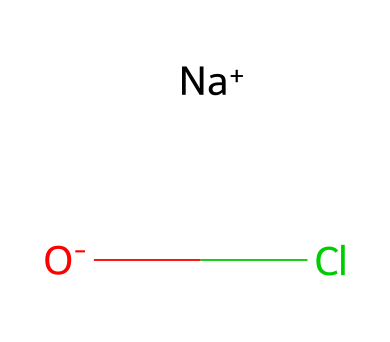What is the main component of sodium hypochlorite? The main component of sodium hypochlorite is the hypochlorite ion (OCl-), which is indicated by the oxygen and chlorine in the SMILES representation.
Answer: hypochlorite ion How many atoms are present in sodium hypochlorite? Counting from the given SMILES representation, there are four atoms: one sodium (Na), one oxygen (O), and one chlorine (Cl), plus the negative charge (O-).
Answer: four atoms What is the oxidation state of chlorine in sodium hypochlorite? In the structure, chlorine (Cl) is part of the hypochlorite ion (OCl-), where it has an oxidation state of +1 as it is bonded to a negatively charged oxygen.
Answer: +1 Is sodium hypochlorite a strong or weak oxidizer? Sodium hypochlorite is considered a strong oxidizer, which is due to the presence of the hypochlorite ion that can readily accept electrons.
Answer: strong oxidizer What type of bond is present between sodium and the hypochlorite ion? The bond between sodium (Na+) and the hypochlorite ion (OCl-) is an ionic bond, as the sodium ion donates an electron to the hypochlorite ion, leading to an electrostatic attraction.
Answer: ionic bond What role does sodium hypochlorite play in household cleaners? Sodium hypochlorite acts as a disinfectant and bleaching agent, making it effective for killing bacteria and removing stains.
Answer: disinfectant and bleaching agent 